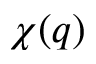<formula> <loc_0><loc_0><loc_500><loc_500>\chi ( q )</formula> 